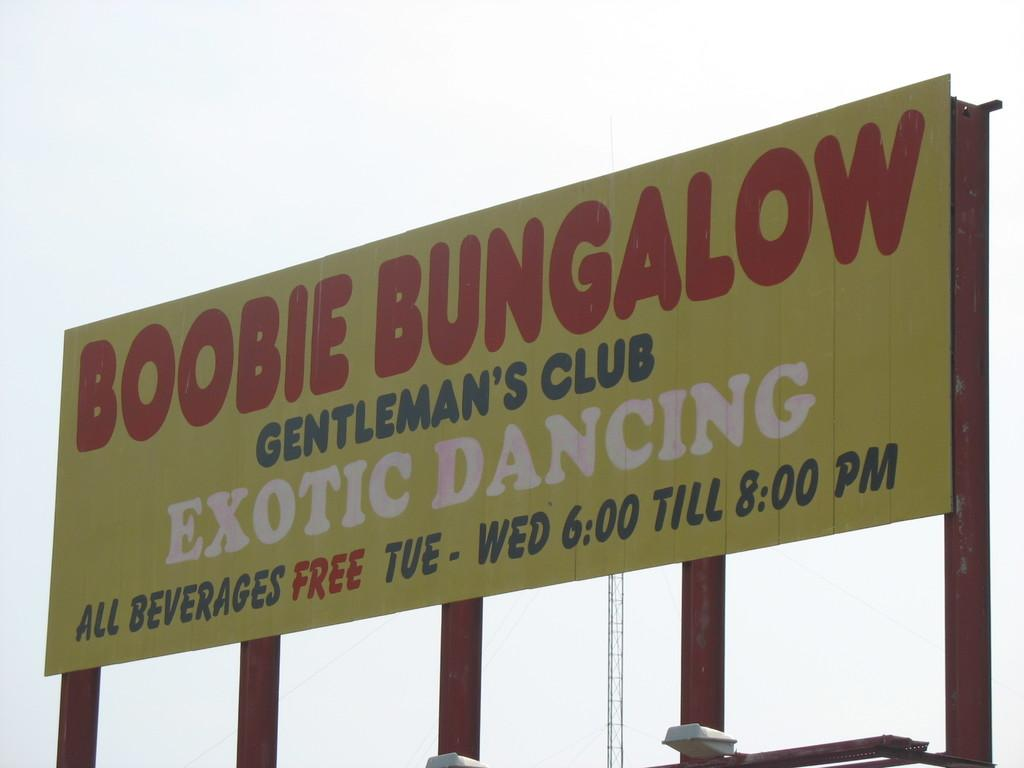<image>
Create a compact narrative representing the image presented. a billboard that says 'boobie bungalow gentleman's club exotic dancing' on it 